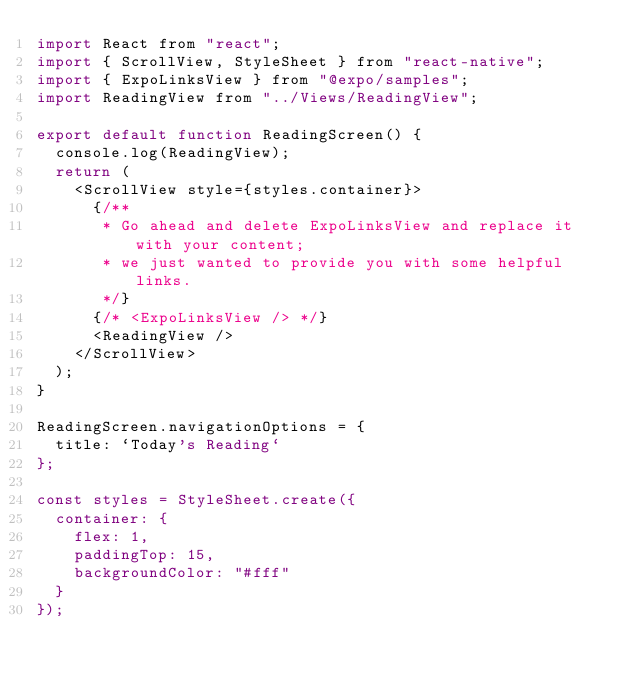Convert code to text. <code><loc_0><loc_0><loc_500><loc_500><_JavaScript_>import React from "react";
import { ScrollView, StyleSheet } from "react-native";
import { ExpoLinksView } from "@expo/samples";
import ReadingView from "../Views/ReadingView";

export default function ReadingScreen() {
  console.log(ReadingView);
  return (
    <ScrollView style={styles.container}>
      {/**
       * Go ahead and delete ExpoLinksView and replace it with your content;
       * we just wanted to provide you with some helpful links.
       */}
      {/* <ExpoLinksView /> */}
      <ReadingView />
    </ScrollView>
  );
}

ReadingScreen.navigationOptions = {
  title: `Today's Reading`
};

const styles = StyleSheet.create({
  container: {
    flex: 1,
    paddingTop: 15,
    backgroundColor: "#fff"
  }
});
</code> 